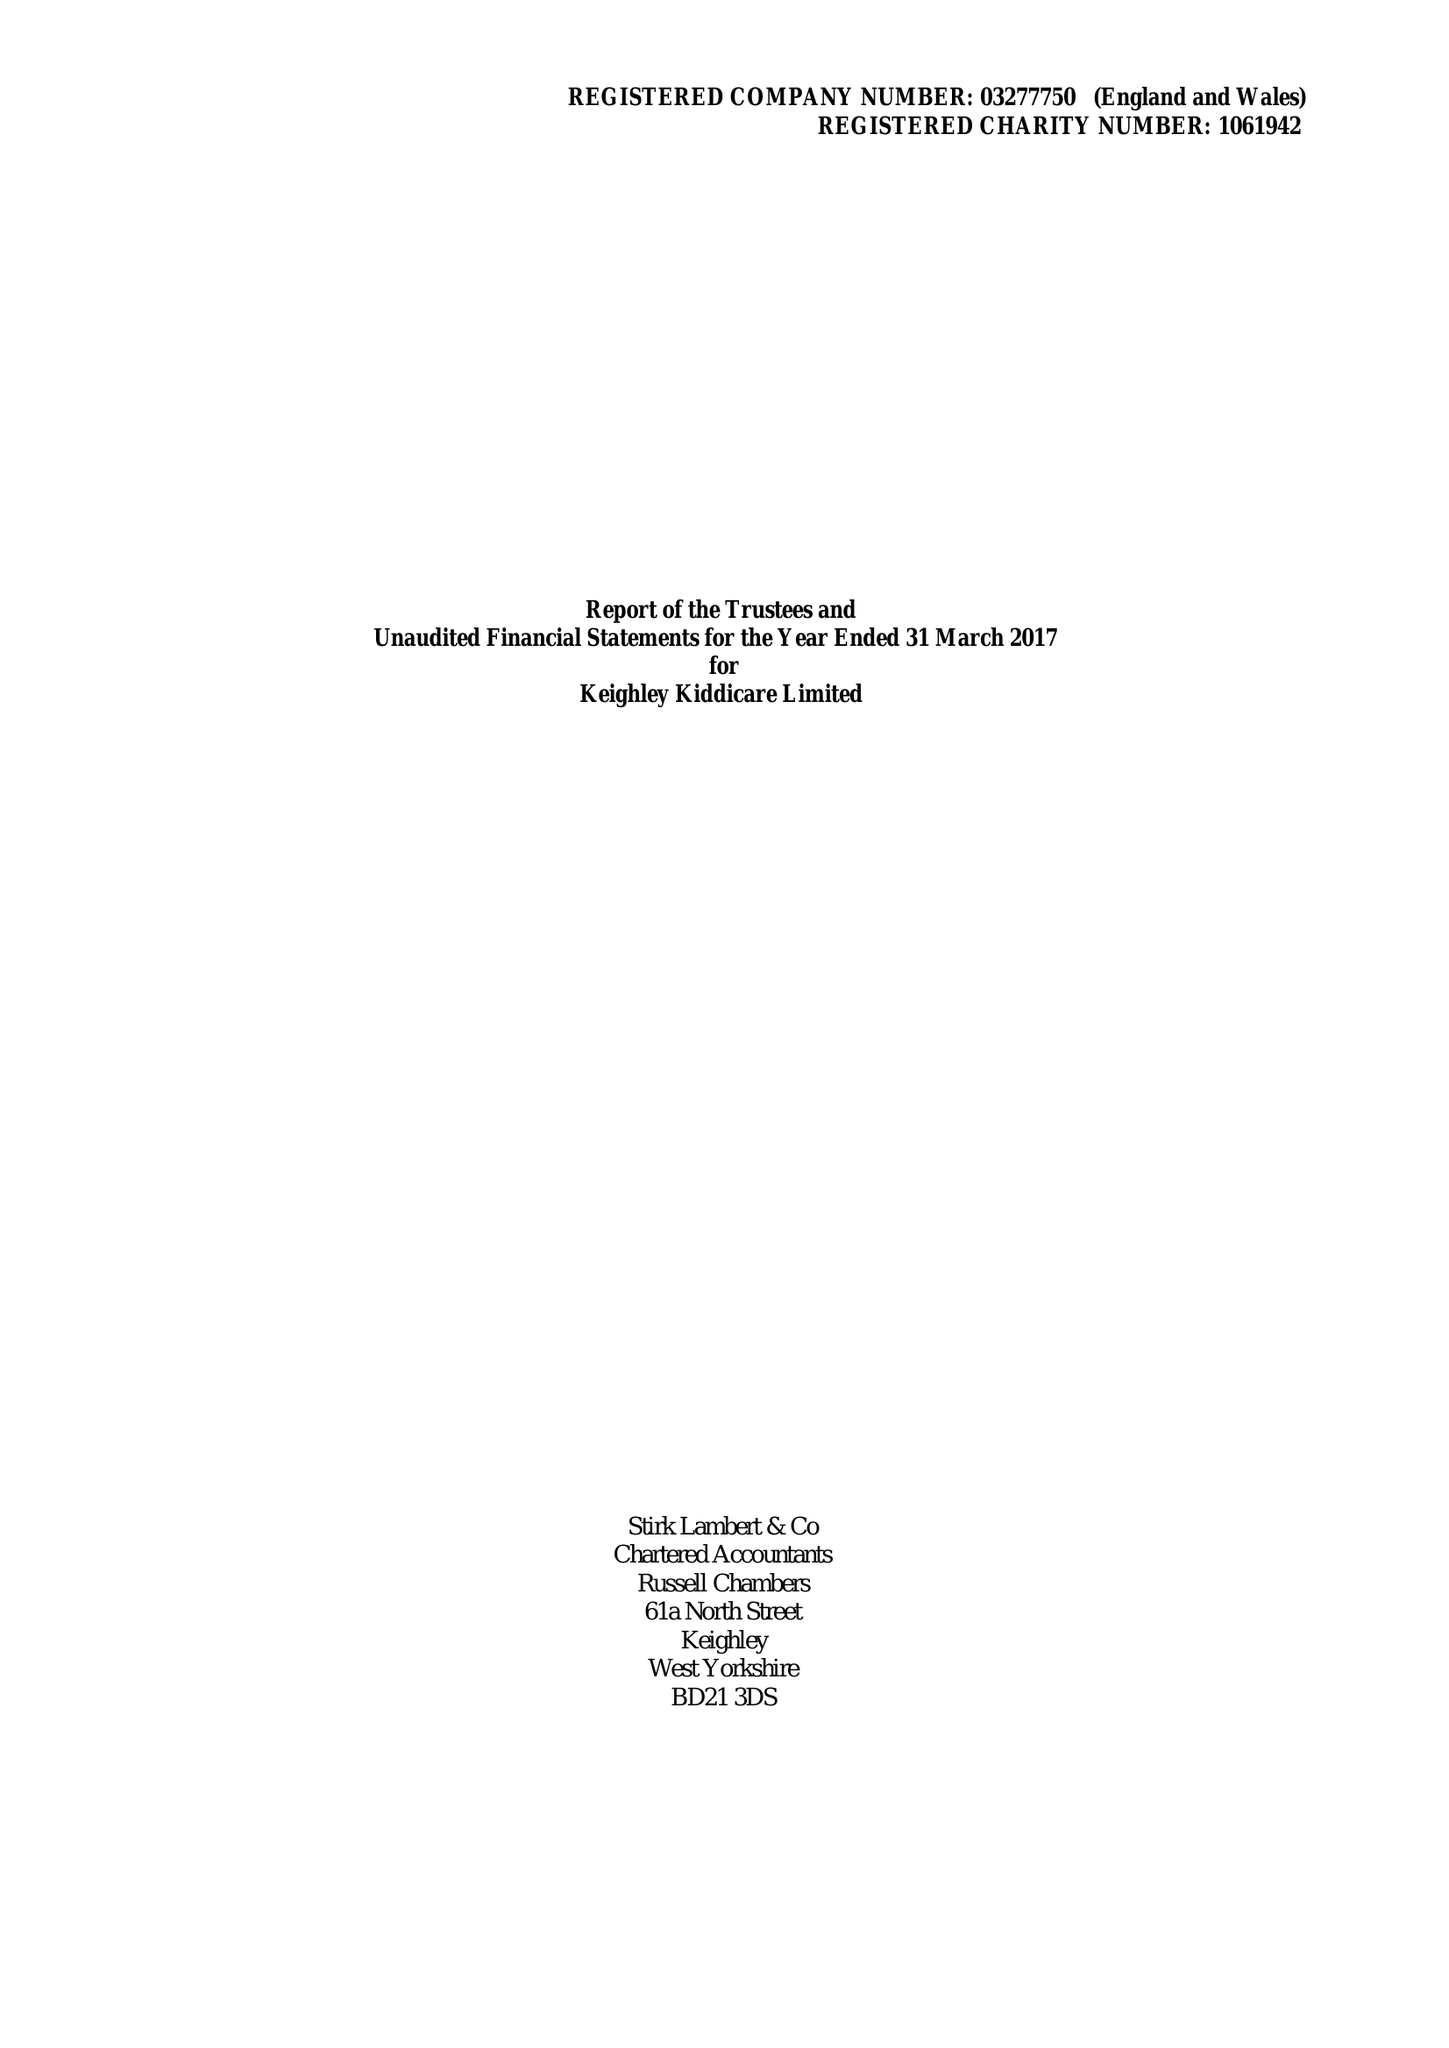What is the value for the address__post_town?
Answer the question using a single word or phrase. KEIGHLEY 